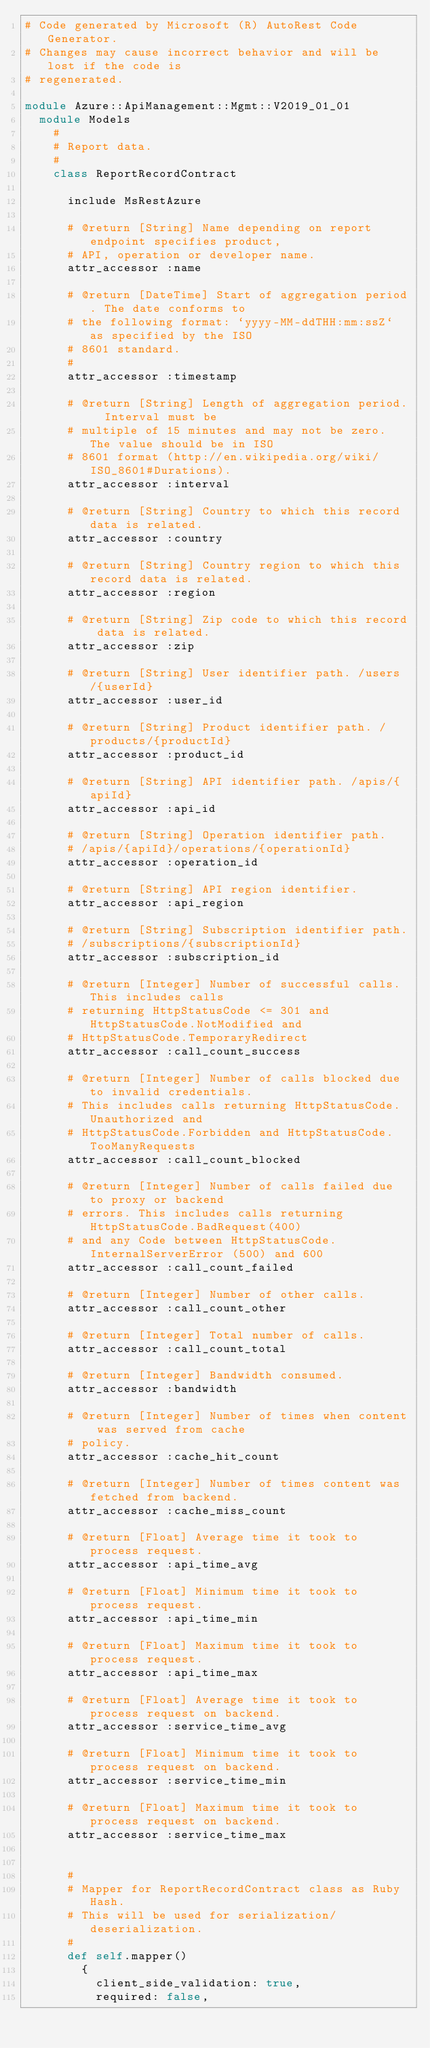<code> <loc_0><loc_0><loc_500><loc_500><_Ruby_># Code generated by Microsoft (R) AutoRest Code Generator.
# Changes may cause incorrect behavior and will be lost if the code is
# regenerated.

module Azure::ApiManagement::Mgmt::V2019_01_01
  module Models
    #
    # Report data.
    #
    class ReportRecordContract

      include MsRestAzure

      # @return [String] Name depending on report endpoint specifies product,
      # API, operation or developer name.
      attr_accessor :name

      # @return [DateTime] Start of aggregation period. The date conforms to
      # the following format: `yyyy-MM-ddTHH:mm:ssZ` as specified by the ISO
      # 8601 standard.
      #
      attr_accessor :timestamp

      # @return [String] Length of aggregation period.  Interval must be
      # multiple of 15 minutes and may not be zero. The value should be in ISO
      # 8601 format (http://en.wikipedia.org/wiki/ISO_8601#Durations).
      attr_accessor :interval

      # @return [String] Country to which this record data is related.
      attr_accessor :country

      # @return [String] Country region to which this record data is related.
      attr_accessor :region

      # @return [String] Zip code to which this record data is related.
      attr_accessor :zip

      # @return [String] User identifier path. /users/{userId}
      attr_accessor :user_id

      # @return [String] Product identifier path. /products/{productId}
      attr_accessor :product_id

      # @return [String] API identifier path. /apis/{apiId}
      attr_accessor :api_id

      # @return [String] Operation identifier path.
      # /apis/{apiId}/operations/{operationId}
      attr_accessor :operation_id

      # @return [String] API region identifier.
      attr_accessor :api_region

      # @return [String] Subscription identifier path.
      # /subscriptions/{subscriptionId}
      attr_accessor :subscription_id

      # @return [Integer] Number of successful calls. This includes calls
      # returning HttpStatusCode <= 301 and HttpStatusCode.NotModified and
      # HttpStatusCode.TemporaryRedirect
      attr_accessor :call_count_success

      # @return [Integer] Number of calls blocked due to invalid credentials.
      # This includes calls returning HttpStatusCode.Unauthorized and
      # HttpStatusCode.Forbidden and HttpStatusCode.TooManyRequests
      attr_accessor :call_count_blocked

      # @return [Integer] Number of calls failed due to proxy or backend
      # errors. This includes calls returning HttpStatusCode.BadRequest(400)
      # and any Code between HttpStatusCode.InternalServerError (500) and 600
      attr_accessor :call_count_failed

      # @return [Integer] Number of other calls.
      attr_accessor :call_count_other

      # @return [Integer] Total number of calls.
      attr_accessor :call_count_total

      # @return [Integer] Bandwidth consumed.
      attr_accessor :bandwidth

      # @return [Integer] Number of times when content was served from cache
      # policy.
      attr_accessor :cache_hit_count

      # @return [Integer] Number of times content was fetched from backend.
      attr_accessor :cache_miss_count

      # @return [Float] Average time it took to process request.
      attr_accessor :api_time_avg

      # @return [Float] Minimum time it took to process request.
      attr_accessor :api_time_min

      # @return [Float] Maximum time it took to process request.
      attr_accessor :api_time_max

      # @return [Float] Average time it took to process request on backend.
      attr_accessor :service_time_avg

      # @return [Float] Minimum time it took to process request on backend.
      attr_accessor :service_time_min

      # @return [Float] Maximum time it took to process request on backend.
      attr_accessor :service_time_max


      #
      # Mapper for ReportRecordContract class as Ruby Hash.
      # This will be used for serialization/deserialization.
      #
      def self.mapper()
        {
          client_side_validation: true,
          required: false,</code> 